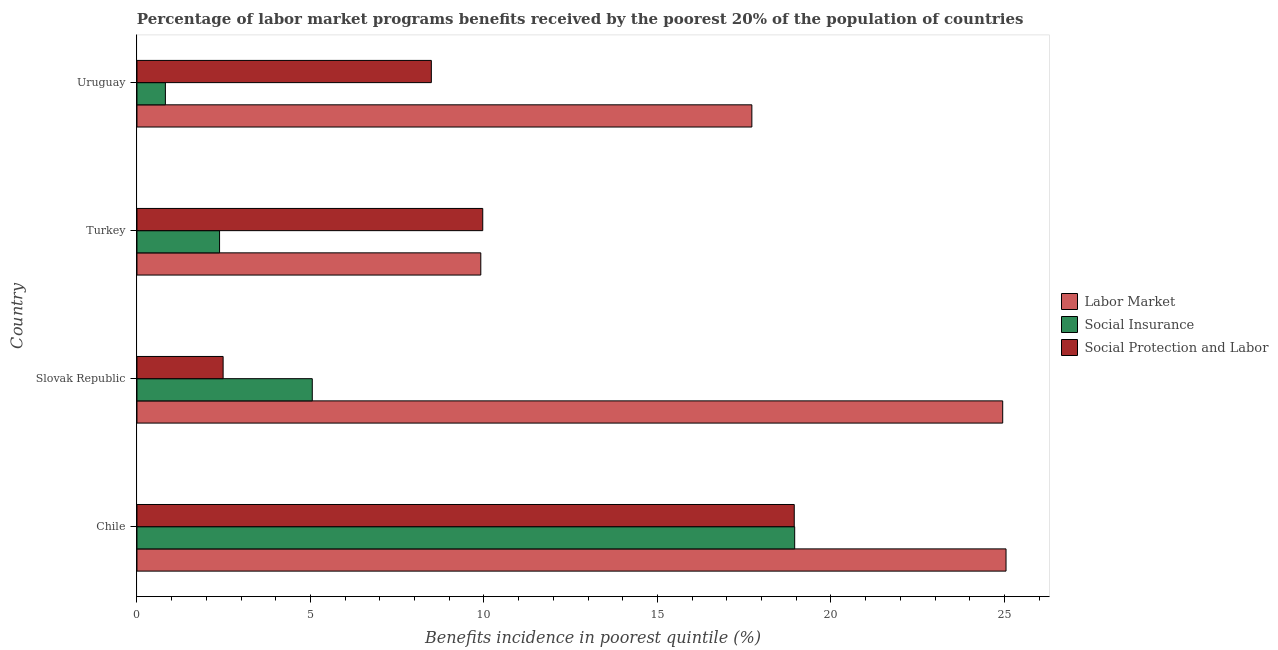How many different coloured bars are there?
Make the answer very short. 3. How many groups of bars are there?
Provide a short and direct response. 4. Are the number of bars per tick equal to the number of legend labels?
Provide a succinct answer. Yes. What is the label of the 2nd group of bars from the top?
Your answer should be very brief. Turkey. What is the percentage of benefits received due to labor market programs in Turkey?
Give a very brief answer. 9.91. Across all countries, what is the maximum percentage of benefits received due to social protection programs?
Make the answer very short. 18.94. Across all countries, what is the minimum percentage of benefits received due to labor market programs?
Provide a succinct answer. 9.91. In which country was the percentage of benefits received due to labor market programs maximum?
Ensure brevity in your answer.  Chile. In which country was the percentage of benefits received due to social protection programs minimum?
Offer a very short reply. Slovak Republic. What is the total percentage of benefits received due to labor market programs in the graph?
Your response must be concise. 77.62. What is the difference between the percentage of benefits received due to labor market programs in Chile and that in Turkey?
Give a very brief answer. 15.14. What is the difference between the percentage of benefits received due to labor market programs in Turkey and the percentage of benefits received due to social protection programs in Chile?
Your response must be concise. -9.03. What is the average percentage of benefits received due to social protection programs per country?
Your answer should be very brief. 9.97. What is the difference between the percentage of benefits received due to social protection programs and percentage of benefits received due to social insurance programs in Uruguay?
Ensure brevity in your answer.  7.66. In how many countries, is the percentage of benefits received due to social protection programs greater than 23 %?
Offer a very short reply. 0. What is the ratio of the percentage of benefits received due to social protection programs in Slovak Republic to that in Uruguay?
Offer a terse response. 0.29. Is the difference between the percentage of benefits received due to social protection programs in Chile and Turkey greater than the difference between the percentage of benefits received due to social insurance programs in Chile and Turkey?
Your answer should be very brief. No. What is the difference between the highest and the second highest percentage of benefits received due to social insurance programs?
Make the answer very short. 13.9. What is the difference between the highest and the lowest percentage of benefits received due to social insurance programs?
Your response must be concise. 18.14. What does the 3rd bar from the top in Chile represents?
Ensure brevity in your answer.  Labor Market. What does the 3rd bar from the bottom in Turkey represents?
Your answer should be compact. Social Protection and Labor. Are all the bars in the graph horizontal?
Provide a succinct answer. Yes. What is the difference between two consecutive major ticks on the X-axis?
Offer a very short reply. 5. Does the graph contain grids?
Keep it short and to the point. No. Where does the legend appear in the graph?
Keep it short and to the point. Center right. How many legend labels are there?
Provide a short and direct response. 3. How are the legend labels stacked?
Keep it short and to the point. Vertical. What is the title of the graph?
Provide a succinct answer. Percentage of labor market programs benefits received by the poorest 20% of the population of countries. Does "Natural Gas" appear as one of the legend labels in the graph?
Offer a terse response. No. What is the label or title of the X-axis?
Give a very brief answer. Benefits incidence in poorest quintile (%). What is the Benefits incidence in poorest quintile (%) of Labor Market in Chile?
Your answer should be compact. 25.05. What is the Benefits incidence in poorest quintile (%) in Social Insurance in Chile?
Keep it short and to the point. 18.95. What is the Benefits incidence in poorest quintile (%) of Social Protection and Labor in Chile?
Give a very brief answer. 18.94. What is the Benefits incidence in poorest quintile (%) of Labor Market in Slovak Republic?
Ensure brevity in your answer.  24.95. What is the Benefits incidence in poorest quintile (%) of Social Insurance in Slovak Republic?
Offer a terse response. 5.05. What is the Benefits incidence in poorest quintile (%) in Social Protection and Labor in Slovak Republic?
Your answer should be very brief. 2.48. What is the Benefits incidence in poorest quintile (%) in Labor Market in Turkey?
Make the answer very short. 9.91. What is the Benefits incidence in poorest quintile (%) in Social Insurance in Turkey?
Offer a very short reply. 2.38. What is the Benefits incidence in poorest quintile (%) of Social Protection and Labor in Turkey?
Offer a terse response. 9.97. What is the Benefits incidence in poorest quintile (%) of Labor Market in Uruguay?
Give a very brief answer. 17.72. What is the Benefits incidence in poorest quintile (%) in Social Insurance in Uruguay?
Your answer should be very brief. 0.82. What is the Benefits incidence in poorest quintile (%) in Social Protection and Labor in Uruguay?
Ensure brevity in your answer.  8.48. Across all countries, what is the maximum Benefits incidence in poorest quintile (%) of Labor Market?
Offer a terse response. 25.05. Across all countries, what is the maximum Benefits incidence in poorest quintile (%) in Social Insurance?
Provide a succinct answer. 18.95. Across all countries, what is the maximum Benefits incidence in poorest quintile (%) of Social Protection and Labor?
Your response must be concise. 18.94. Across all countries, what is the minimum Benefits incidence in poorest quintile (%) in Labor Market?
Your answer should be very brief. 9.91. Across all countries, what is the minimum Benefits incidence in poorest quintile (%) of Social Insurance?
Offer a very short reply. 0.82. Across all countries, what is the minimum Benefits incidence in poorest quintile (%) in Social Protection and Labor?
Offer a very short reply. 2.48. What is the total Benefits incidence in poorest quintile (%) in Labor Market in the graph?
Your response must be concise. 77.62. What is the total Benefits incidence in poorest quintile (%) in Social Insurance in the graph?
Keep it short and to the point. 27.21. What is the total Benefits incidence in poorest quintile (%) in Social Protection and Labor in the graph?
Keep it short and to the point. 39.87. What is the difference between the Benefits incidence in poorest quintile (%) of Labor Market in Chile and that in Slovak Republic?
Keep it short and to the point. 0.1. What is the difference between the Benefits incidence in poorest quintile (%) of Social Insurance in Chile and that in Slovak Republic?
Offer a terse response. 13.9. What is the difference between the Benefits incidence in poorest quintile (%) of Social Protection and Labor in Chile and that in Slovak Republic?
Ensure brevity in your answer.  16.46. What is the difference between the Benefits incidence in poorest quintile (%) of Labor Market in Chile and that in Turkey?
Your answer should be compact. 15.14. What is the difference between the Benefits incidence in poorest quintile (%) of Social Insurance in Chile and that in Turkey?
Your response must be concise. 16.57. What is the difference between the Benefits incidence in poorest quintile (%) of Social Protection and Labor in Chile and that in Turkey?
Give a very brief answer. 8.98. What is the difference between the Benefits incidence in poorest quintile (%) in Labor Market in Chile and that in Uruguay?
Offer a terse response. 7.33. What is the difference between the Benefits incidence in poorest quintile (%) in Social Insurance in Chile and that in Uruguay?
Your answer should be very brief. 18.14. What is the difference between the Benefits incidence in poorest quintile (%) of Social Protection and Labor in Chile and that in Uruguay?
Offer a terse response. 10.46. What is the difference between the Benefits incidence in poorest quintile (%) of Labor Market in Slovak Republic and that in Turkey?
Keep it short and to the point. 15.04. What is the difference between the Benefits incidence in poorest quintile (%) in Social Insurance in Slovak Republic and that in Turkey?
Keep it short and to the point. 2.67. What is the difference between the Benefits incidence in poorest quintile (%) of Social Protection and Labor in Slovak Republic and that in Turkey?
Offer a terse response. -7.48. What is the difference between the Benefits incidence in poorest quintile (%) of Labor Market in Slovak Republic and that in Uruguay?
Offer a terse response. 7.23. What is the difference between the Benefits incidence in poorest quintile (%) in Social Insurance in Slovak Republic and that in Uruguay?
Provide a short and direct response. 4.23. What is the difference between the Benefits incidence in poorest quintile (%) in Social Protection and Labor in Slovak Republic and that in Uruguay?
Provide a succinct answer. -6. What is the difference between the Benefits incidence in poorest quintile (%) of Labor Market in Turkey and that in Uruguay?
Give a very brief answer. -7.81. What is the difference between the Benefits incidence in poorest quintile (%) in Social Insurance in Turkey and that in Uruguay?
Make the answer very short. 1.56. What is the difference between the Benefits incidence in poorest quintile (%) of Social Protection and Labor in Turkey and that in Uruguay?
Provide a short and direct response. 1.48. What is the difference between the Benefits incidence in poorest quintile (%) of Labor Market in Chile and the Benefits incidence in poorest quintile (%) of Social Insurance in Slovak Republic?
Your response must be concise. 19.99. What is the difference between the Benefits incidence in poorest quintile (%) of Labor Market in Chile and the Benefits incidence in poorest quintile (%) of Social Protection and Labor in Slovak Republic?
Make the answer very short. 22.56. What is the difference between the Benefits incidence in poorest quintile (%) of Social Insurance in Chile and the Benefits incidence in poorest quintile (%) of Social Protection and Labor in Slovak Republic?
Give a very brief answer. 16.47. What is the difference between the Benefits incidence in poorest quintile (%) of Labor Market in Chile and the Benefits incidence in poorest quintile (%) of Social Insurance in Turkey?
Offer a terse response. 22.67. What is the difference between the Benefits incidence in poorest quintile (%) in Labor Market in Chile and the Benefits incidence in poorest quintile (%) in Social Protection and Labor in Turkey?
Offer a very short reply. 15.08. What is the difference between the Benefits incidence in poorest quintile (%) of Social Insurance in Chile and the Benefits incidence in poorest quintile (%) of Social Protection and Labor in Turkey?
Provide a short and direct response. 8.99. What is the difference between the Benefits incidence in poorest quintile (%) of Labor Market in Chile and the Benefits incidence in poorest quintile (%) of Social Insurance in Uruguay?
Offer a very short reply. 24.23. What is the difference between the Benefits incidence in poorest quintile (%) of Labor Market in Chile and the Benefits incidence in poorest quintile (%) of Social Protection and Labor in Uruguay?
Your answer should be very brief. 16.56. What is the difference between the Benefits incidence in poorest quintile (%) in Social Insurance in Chile and the Benefits incidence in poorest quintile (%) in Social Protection and Labor in Uruguay?
Provide a short and direct response. 10.47. What is the difference between the Benefits incidence in poorest quintile (%) in Labor Market in Slovak Republic and the Benefits incidence in poorest quintile (%) in Social Insurance in Turkey?
Keep it short and to the point. 22.57. What is the difference between the Benefits incidence in poorest quintile (%) of Labor Market in Slovak Republic and the Benefits incidence in poorest quintile (%) of Social Protection and Labor in Turkey?
Keep it short and to the point. 14.98. What is the difference between the Benefits incidence in poorest quintile (%) in Social Insurance in Slovak Republic and the Benefits incidence in poorest quintile (%) in Social Protection and Labor in Turkey?
Keep it short and to the point. -4.91. What is the difference between the Benefits incidence in poorest quintile (%) in Labor Market in Slovak Republic and the Benefits incidence in poorest quintile (%) in Social Insurance in Uruguay?
Ensure brevity in your answer.  24.13. What is the difference between the Benefits incidence in poorest quintile (%) of Labor Market in Slovak Republic and the Benefits incidence in poorest quintile (%) of Social Protection and Labor in Uruguay?
Your answer should be compact. 16.47. What is the difference between the Benefits incidence in poorest quintile (%) of Social Insurance in Slovak Republic and the Benefits incidence in poorest quintile (%) of Social Protection and Labor in Uruguay?
Keep it short and to the point. -3.43. What is the difference between the Benefits incidence in poorest quintile (%) of Labor Market in Turkey and the Benefits incidence in poorest quintile (%) of Social Insurance in Uruguay?
Give a very brief answer. 9.09. What is the difference between the Benefits incidence in poorest quintile (%) in Labor Market in Turkey and the Benefits incidence in poorest quintile (%) in Social Protection and Labor in Uruguay?
Your answer should be compact. 1.43. What is the difference between the Benefits incidence in poorest quintile (%) in Social Insurance in Turkey and the Benefits incidence in poorest quintile (%) in Social Protection and Labor in Uruguay?
Provide a short and direct response. -6.1. What is the average Benefits incidence in poorest quintile (%) in Labor Market per country?
Keep it short and to the point. 19.41. What is the average Benefits incidence in poorest quintile (%) in Social Insurance per country?
Make the answer very short. 6.8. What is the average Benefits incidence in poorest quintile (%) in Social Protection and Labor per country?
Ensure brevity in your answer.  9.97. What is the difference between the Benefits incidence in poorest quintile (%) in Labor Market and Benefits incidence in poorest quintile (%) in Social Insurance in Chile?
Give a very brief answer. 6.09. What is the difference between the Benefits incidence in poorest quintile (%) of Labor Market and Benefits incidence in poorest quintile (%) of Social Protection and Labor in Chile?
Ensure brevity in your answer.  6.1. What is the difference between the Benefits incidence in poorest quintile (%) of Social Insurance and Benefits incidence in poorest quintile (%) of Social Protection and Labor in Chile?
Offer a very short reply. 0.01. What is the difference between the Benefits incidence in poorest quintile (%) of Labor Market and Benefits incidence in poorest quintile (%) of Social Insurance in Slovak Republic?
Offer a terse response. 19.9. What is the difference between the Benefits incidence in poorest quintile (%) in Labor Market and Benefits incidence in poorest quintile (%) in Social Protection and Labor in Slovak Republic?
Your answer should be compact. 22.47. What is the difference between the Benefits incidence in poorest quintile (%) in Social Insurance and Benefits incidence in poorest quintile (%) in Social Protection and Labor in Slovak Republic?
Give a very brief answer. 2.57. What is the difference between the Benefits incidence in poorest quintile (%) in Labor Market and Benefits incidence in poorest quintile (%) in Social Insurance in Turkey?
Make the answer very short. 7.53. What is the difference between the Benefits incidence in poorest quintile (%) in Labor Market and Benefits incidence in poorest quintile (%) in Social Protection and Labor in Turkey?
Provide a short and direct response. -0.06. What is the difference between the Benefits incidence in poorest quintile (%) in Social Insurance and Benefits incidence in poorest quintile (%) in Social Protection and Labor in Turkey?
Offer a terse response. -7.58. What is the difference between the Benefits incidence in poorest quintile (%) in Labor Market and Benefits incidence in poorest quintile (%) in Social Insurance in Uruguay?
Ensure brevity in your answer.  16.9. What is the difference between the Benefits incidence in poorest quintile (%) of Labor Market and Benefits incidence in poorest quintile (%) of Social Protection and Labor in Uruguay?
Your answer should be compact. 9.24. What is the difference between the Benefits incidence in poorest quintile (%) in Social Insurance and Benefits incidence in poorest quintile (%) in Social Protection and Labor in Uruguay?
Make the answer very short. -7.66. What is the ratio of the Benefits incidence in poorest quintile (%) of Labor Market in Chile to that in Slovak Republic?
Keep it short and to the point. 1. What is the ratio of the Benefits incidence in poorest quintile (%) of Social Insurance in Chile to that in Slovak Republic?
Provide a short and direct response. 3.75. What is the ratio of the Benefits incidence in poorest quintile (%) of Social Protection and Labor in Chile to that in Slovak Republic?
Provide a succinct answer. 7.63. What is the ratio of the Benefits incidence in poorest quintile (%) of Labor Market in Chile to that in Turkey?
Your response must be concise. 2.53. What is the ratio of the Benefits incidence in poorest quintile (%) of Social Insurance in Chile to that in Turkey?
Your answer should be very brief. 7.96. What is the ratio of the Benefits incidence in poorest quintile (%) of Social Protection and Labor in Chile to that in Turkey?
Offer a very short reply. 1.9. What is the ratio of the Benefits incidence in poorest quintile (%) in Labor Market in Chile to that in Uruguay?
Keep it short and to the point. 1.41. What is the ratio of the Benefits incidence in poorest quintile (%) of Social Insurance in Chile to that in Uruguay?
Provide a succinct answer. 23.14. What is the ratio of the Benefits incidence in poorest quintile (%) of Social Protection and Labor in Chile to that in Uruguay?
Offer a terse response. 2.23. What is the ratio of the Benefits incidence in poorest quintile (%) of Labor Market in Slovak Republic to that in Turkey?
Ensure brevity in your answer.  2.52. What is the ratio of the Benefits incidence in poorest quintile (%) of Social Insurance in Slovak Republic to that in Turkey?
Offer a terse response. 2.12. What is the ratio of the Benefits incidence in poorest quintile (%) of Social Protection and Labor in Slovak Republic to that in Turkey?
Make the answer very short. 0.25. What is the ratio of the Benefits incidence in poorest quintile (%) of Labor Market in Slovak Republic to that in Uruguay?
Your response must be concise. 1.41. What is the ratio of the Benefits incidence in poorest quintile (%) of Social Insurance in Slovak Republic to that in Uruguay?
Ensure brevity in your answer.  6.17. What is the ratio of the Benefits incidence in poorest quintile (%) in Social Protection and Labor in Slovak Republic to that in Uruguay?
Keep it short and to the point. 0.29. What is the ratio of the Benefits incidence in poorest quintile (%) in Labor Market in Turkey to that in Uruguay?
Make the answer very short. 0.56. What is the ratio of the Benefits incidence in poorest quintile (%) of Social Insurance in Turkey to that in Uruguay?
Provide a short and direct response. 2.91. What is the ratio of the Benefits incidence in poorest quintile (%) in Social Protection and Labor in Turkey to that in Uruguay?
Provide a succinct answer. 1.17. What is the difference between the highest and the second highest Benefits incidence in poorest quintile (%) of Labor Market?
Your answer should be compact. 0.1. What is the difference between the highest and the second highest Benefits incidence in poorest quintile (%) of Social Insurance?
Provide a succinct answer. 13.9. What is the difference between the highest and the second highest Benefits incidence in poorest quintile (%) in Social Protection and Labor?
Make the answer very short. 8.98. What is the difference between the highest and the lowest Benefits incidence in poorest quintile (%) in Labor Market?
Your answer should be compact. 15.14. What is the difference between the highest and the lowest Benefits incidence in poorest quintile (%) of Social Insurance?
Keep it short and to the point. 18.14. What is the difference between the highest and the lowest Benefits incidence in poorest quintile (%) of Social Protection and Labor?
Your answer should be compact. 16.46. 